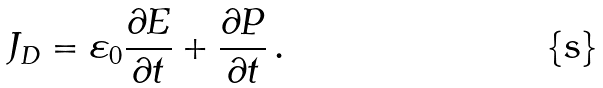<formula> <loc_0><loc_0><loc_500><loc_500>J _ { D } = \varepsilon _ { 0 } { \frac { \partial E } { \partial t } } + { \frac { \partial P } { \partial t } } \, .</formula> 